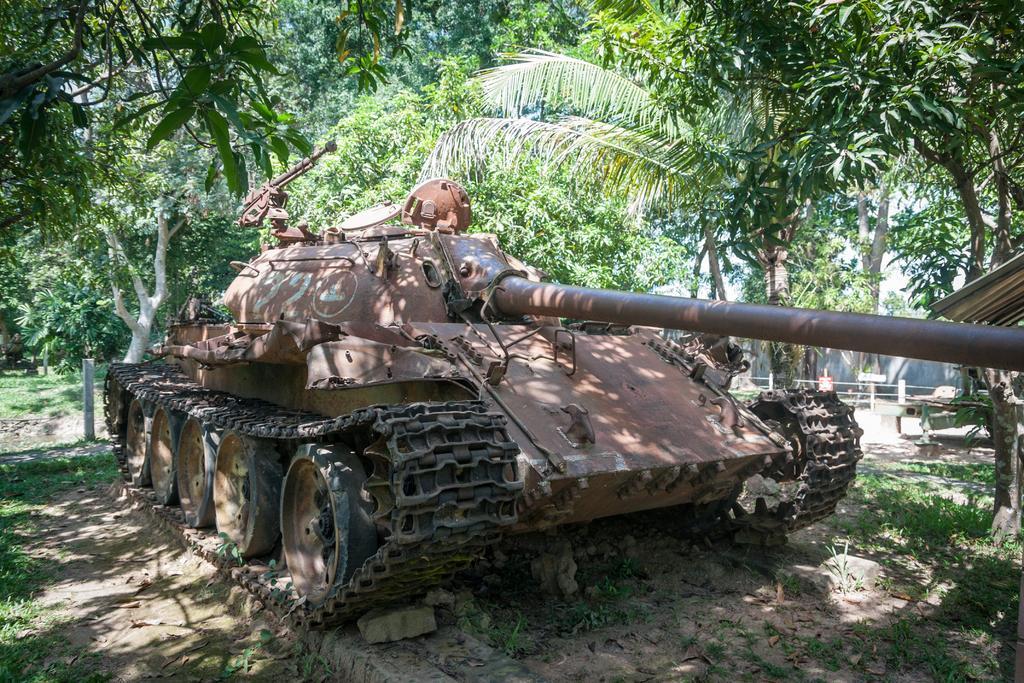Can you describe this image briefly? In the image there is a churchil tank and around the churchil tank there are trees and grass. 